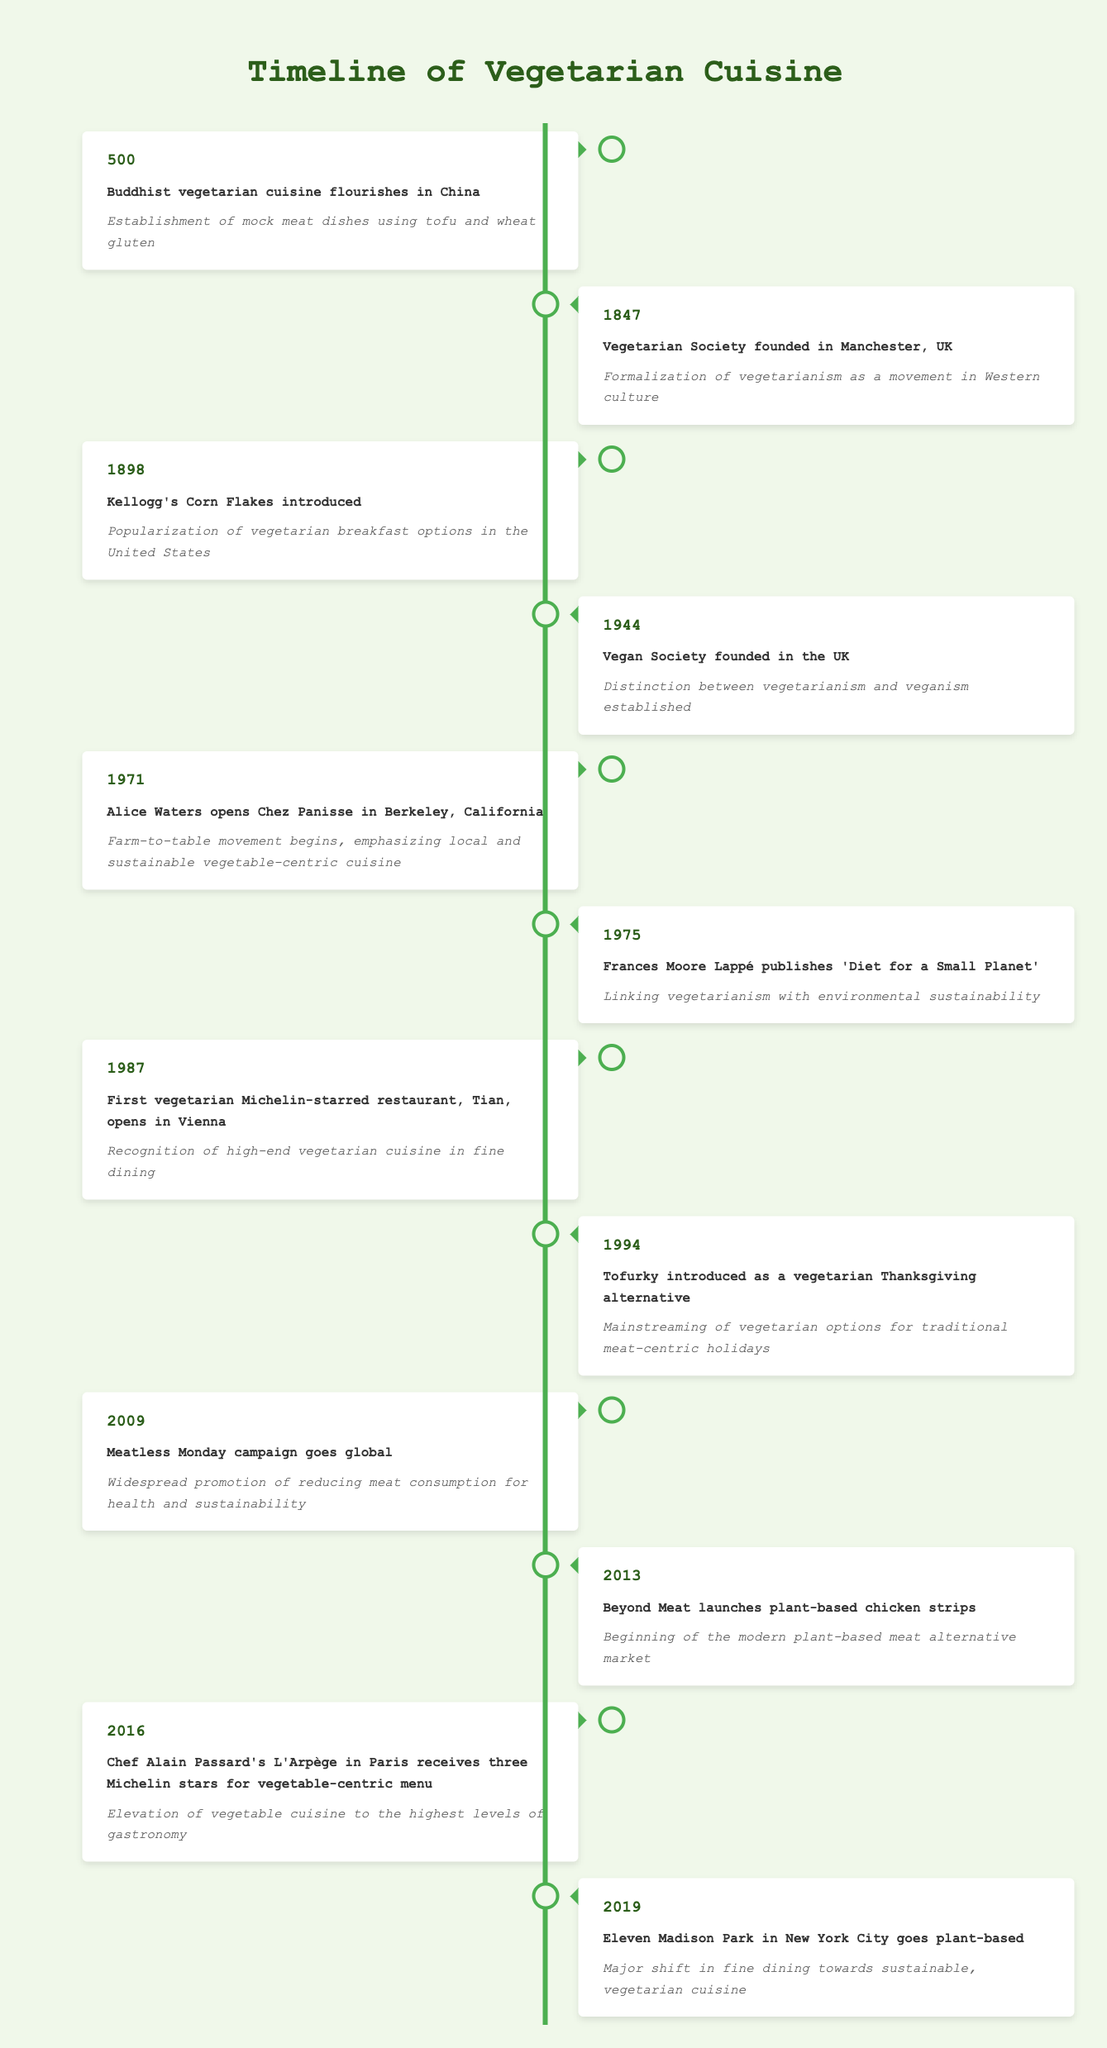What year did the Vegan Society get founded? The table shows the event and year alongside it. By locating the row that talks about the Vegan Society, I see that it was founded in the year 1944.
Answer: 1944 What event in 1898 contributed to the popularity of vegetarianism in breakfast options? The event for 1898 states that Kellogg's Corn Flakes were introduced, which contributed to the popularization of vegetarian breakfast options in the United States.
Answer: Kellogg's Corn Flakes introduced How many years are there between the founding of the Vegetarian Society and the Vegan Society? The Vegetarian Society was founded in 1847 and the Vegan Society in 1944. To find the difference, I subtract: 1944 - 1847 = 97 years.
Answer: 97 years Was the establishment of mock meat dishes linked to Buddhism? The event listed for the year 500 states that Buddhist vegetarian cuisine flourished in China and established mock meat dishes using tofu and wheat gluten, indicating a strong link to Buddhism.
Answer: Yes Which significant event regarding vegetarian cuisine took place in 2016, and what was its significance? The event for 2016 shows that Chef Alain Passard's L'Arpège in Paris received three Michelin stars for its vegetable-centric menu, indicating the elevation of vegetable cuisine within fine dining.
Answer: Chef Alain Passard's L'Arpège received three Michelin stars Which event has the earliest date associated with vegetarian cuisine? Scanning through the timeline, the earliest event is from the year 500, where Buddhist vegetarian cuisine flourished in China.
Answer: 500 In what year did the Meatless Monday campaign gain global traction? The timeline indicates that the Meatless Monday campaign went global in 2009.
Answer: 2009 What impact did Frances Moore Lappé's publication in 1975 have on vegetarianism? The event from 1975 states that Frances Moore Lappé published 'Diet for a Small Planet', linking vegetarianism with environmental sustainability, showing its impact on both diet and environment.
Answer: Linking vegetarianism with environmental sustainability How many vegetarian restaurants were recognized by Michelin stars by 1987? The table mentions that by 1987, the first vegetarian Michelin-starred restaurant, Tian, opened in Vienna, indicating one recognized star at that time for vegetarian cuisine.
Answer: 1 